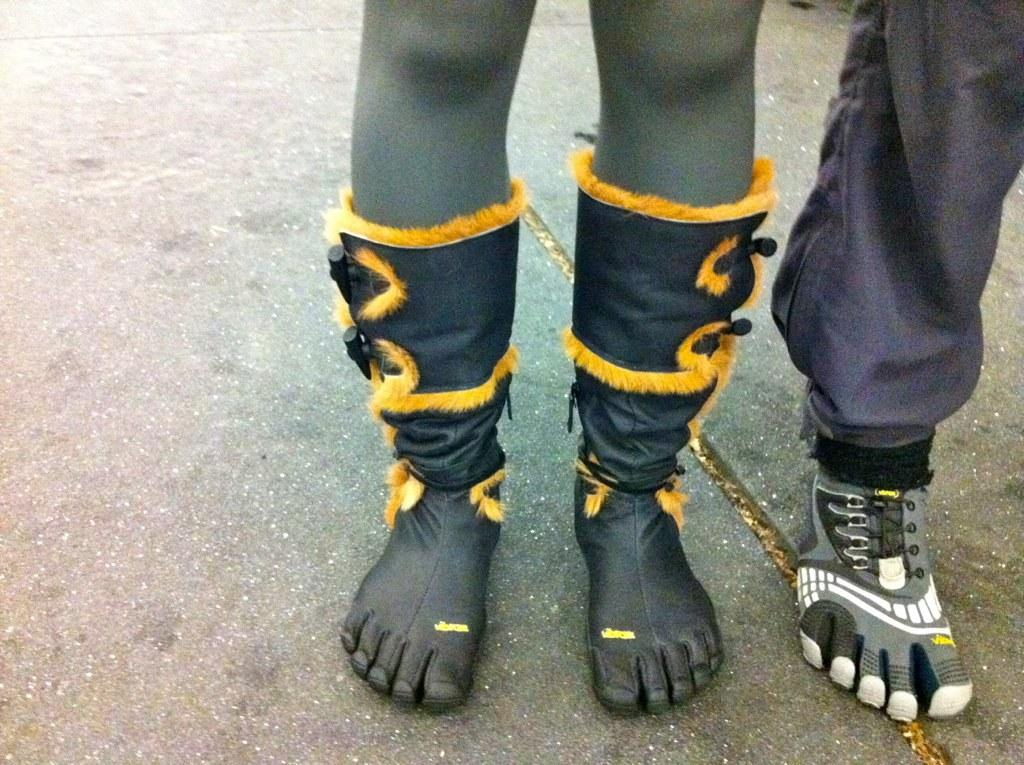How many persons are visible in the image? There are two persons in the image. What can be seen in relation to the persons? The legs of the two persons are visible in the image. Where are the persons standing? The persons are standing on a road. What type of chalk is being used by the persons in the image? There is no chalk present in the image; the persons are standing on a road. How many eggs are visible in the image? There are no eggs present in the image. 